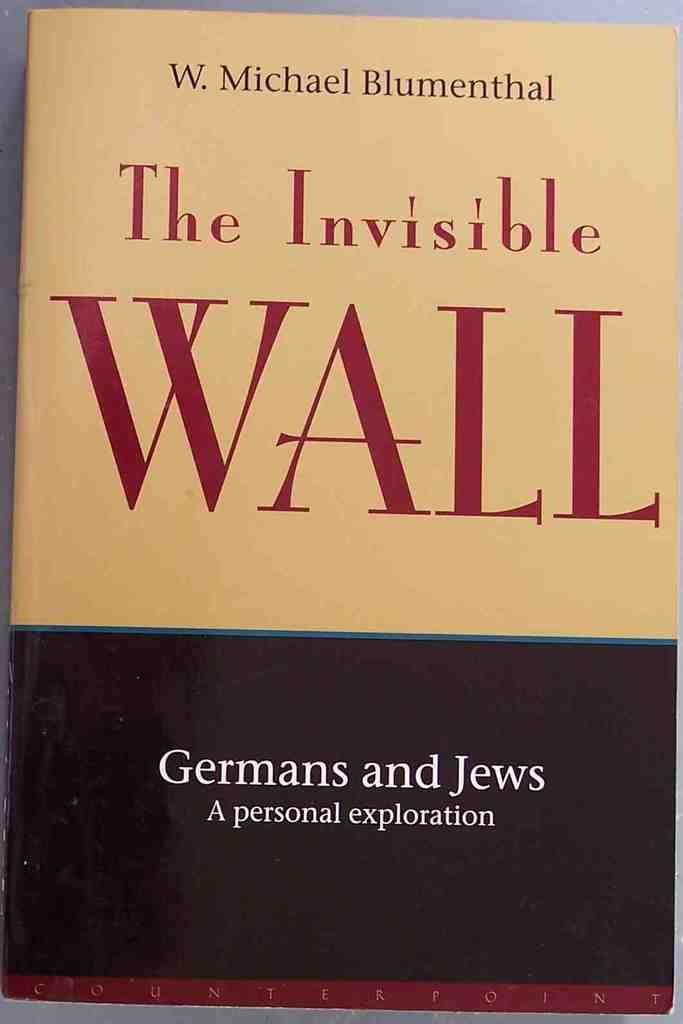<image>
Write a terse but informative summary of the picture. A book written by Michael Blumenthal titled The Invisible Wall 